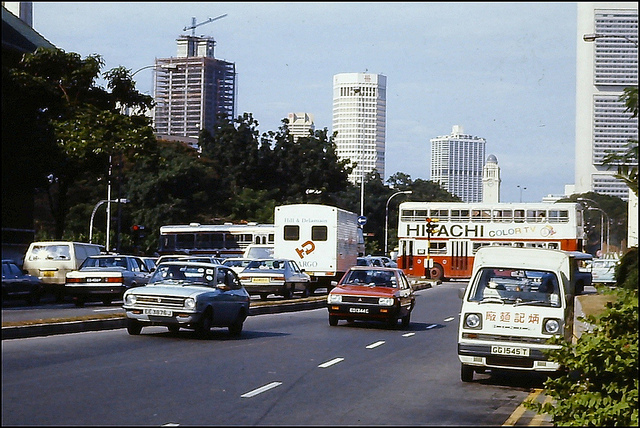What era does this image look like it's from based on the vehicles and infrastructure? The vehicles and cityscape suggest that this image is likely from the late 20th century, characterized by the models of the cars and the architectural styles of the buildings. 